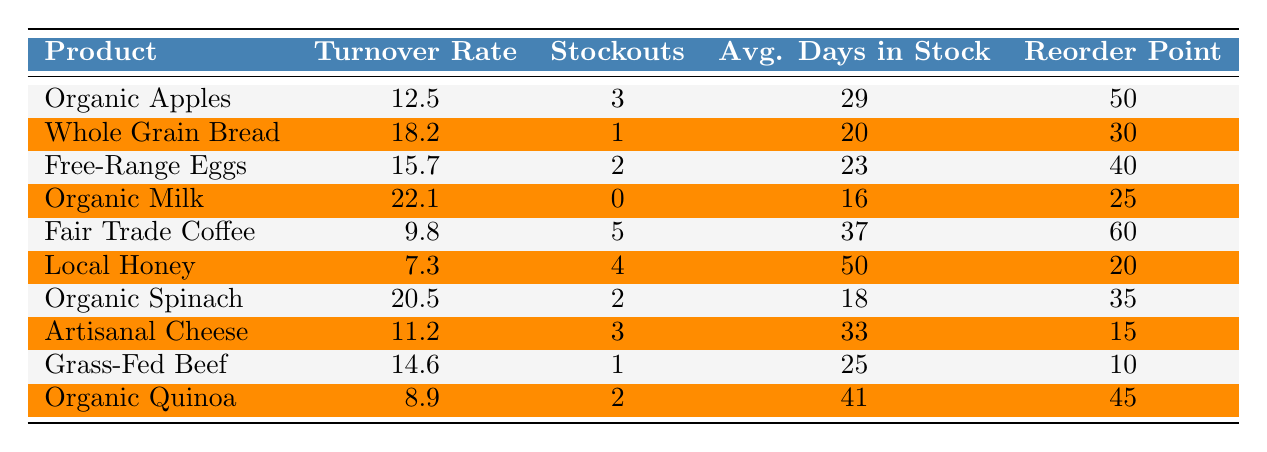What is the inventory turnover rate for Organic Milk? The table shows that the inventory turnover rate for Organic Milk is listed directly in the corresponding row.
Answer: 22.1 How many stockout incidents did Fair Trade Coffee experience? By referencing the row for Fair Trade Coffee, we can see that it experienced 5 stockout incidents.
Answer: 5 Which product has the highest inventory turnover rate? Comparing the inventory turnover rates, Organic Milk has the highest rate at 22.1.
Answer: Organic Milk What is the average number of stockout incidents across all products? To find the average stockout incidents, we sum all stockout incidents (3 + 1 + 2 + 0 + 5 + 4 + 2 + 3 + 1 + 2 = 23) and divide by the number of products (10). Thus, the average is 23 / 10 = 2.3.
Answer: 2.3 Is it true that Local Honey has more stockout incidents than Organic Spinach? Local Honey has 4 stockout incidents while Organic Spinach has 2. Therefore, it is true that Local Honey has more stockout incidents.
Answer: Yes Which product has the lowest average days in stock? By reviewing the average days in stock for each product, we see that Organic Milk has the lowest at 16 days.
Answer: Organic Milk Calculate the total inventory turnover rate for the products with stockout incidents. The total turnover rate for products with stockouts includes Fair Trade Coffee (9.8), Local Honey (7.3), Organic Spinach (20.5), Free-Range Eggs (15.7), and Artisanal Cheese (11.2). The sum is (9.8 + 7.3 + 20.5 + 15.7 + 11.2 = 64.5).
Answer: 64.5 What is the difference in average days in stock between Grass-Fed Beef and Organic Quinoa? Grass-Fed Beef has 25 average days in stock and Organic Quinoa has 41 days, so the difference is 41 - 25 = 16 days.
Answer: 16 Are there any products with a stockout incident count of zero? Upon reviewing the table, Organic Milk is the only product with a stockout incident count of zero.
Answer: Yes Which product requires the highest reorder point? Looking at the reorder points in the table, Fair Trade Coffee has the highest reorder point at 60.
Answer: Fair Trade Coffee 